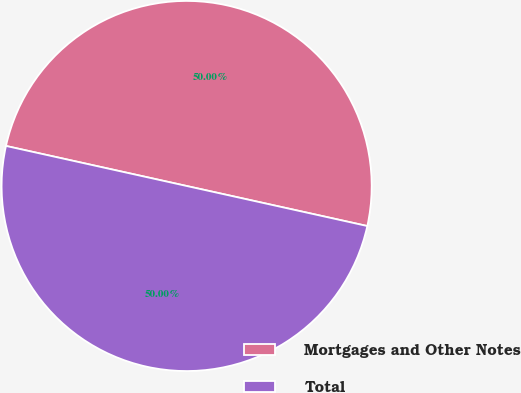<chart> <loc_0><loc_0><loc_500><loc_500><pie_chart><fcel>Mortgages and Other Notes<fcel>Total<nl><fcel>50.0%<fcel>50.0%<nl></chart> 